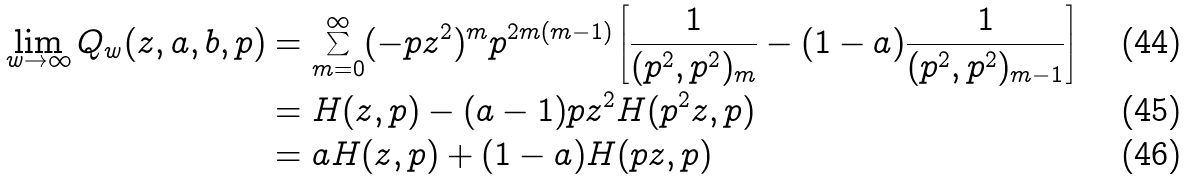<formula> <loc_0><loc_0><loc_500><loc_500>\lim _ { w \rightarrow \infty } Q _ { w } ( z , a , b , p ) & = \sum _ { m = 0 } ^ { \infty } ( - p z ^ { 2 } ) ^ { m } p ^ { 2 m ( m - 1 ) } \left [ \frac { 1 } { ( p ^ { 2 } , p ^ { 2 } ) _ { m } } - ( 1 - a ) \frac { 1 } { ( p ^ { 2 } , p ^ { 2 } ) _ { m - 1 } } \right ] \\ & = H ( z , p ) - ( a - 1 ) p z ^ { 2 } H ( p ^ { 2 } z , p ) \\ & = a H ( z , p ) + ( 1 - a ) H ( p z , p )</formula> 